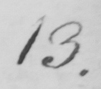What is written in this line of handwriting? 13 . 